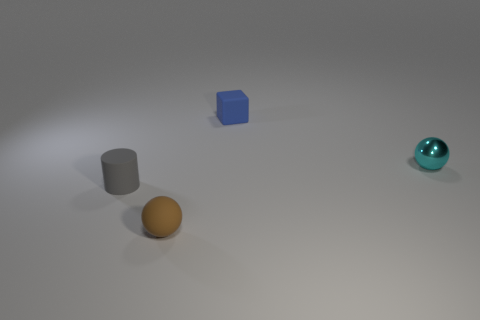Add 4 tiny yellow shiny balls. How many objects exist? 8 Subtract all blocks. How many objects are left? 3 Add 4 blue metallic cylinders. How many blue metallic cylinders exist? 4 Subtract 0 red balls. How many objects are left? 4 Subtract all tiny gray objects. Subtract all tiny matte objects. How many objects are left? 0 Add 2 small brown rubber spheres. How many small brown rubber spheres are left? 3 